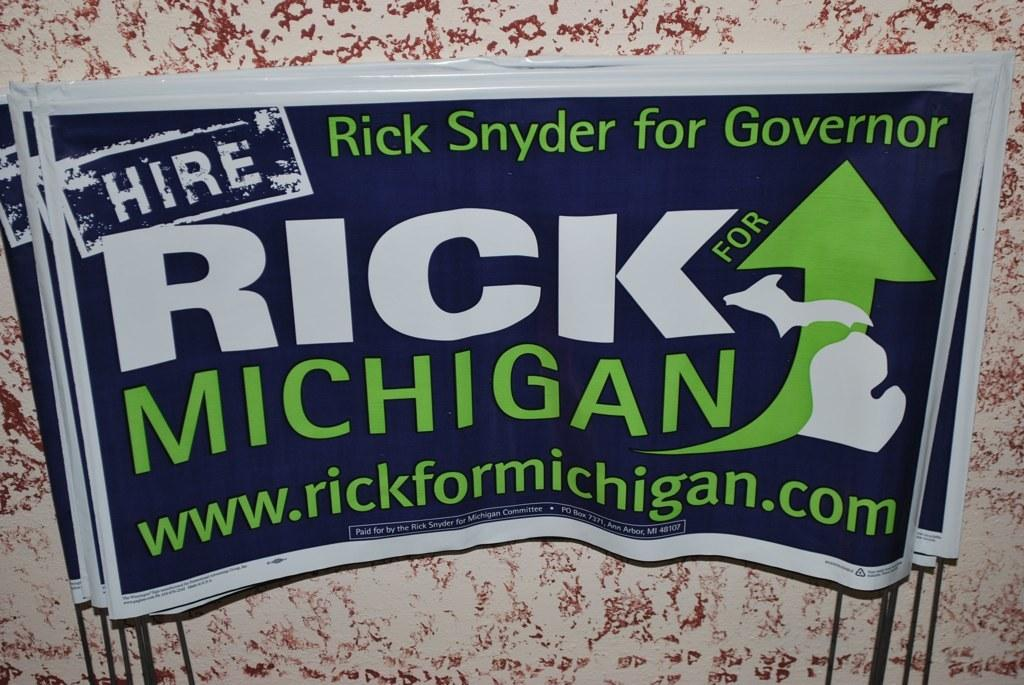<image>
Describe the image concisely. A sticker advertising Rick Synder for governer of Michigan. 